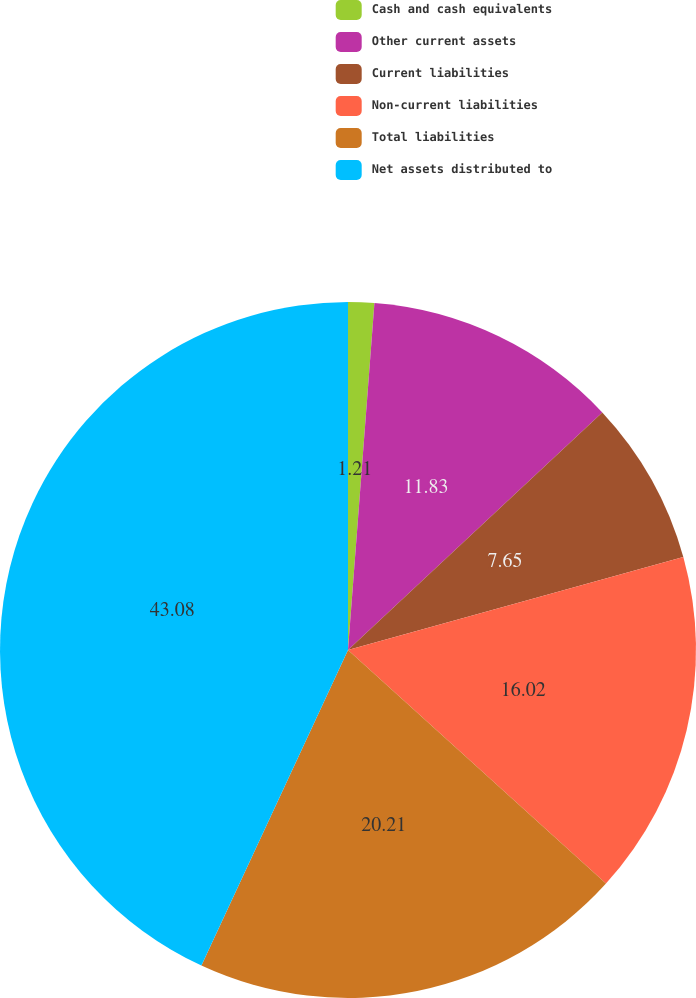Convert chart to OTSL. <chart><loc_0><loc_0><loc_500><loc_500><pie_chart><fcel>Cash and cash equivalents<fcel>Other current assets<fcel>Current liabilities<fcel>Non-current liabilities<fcel>Total liabilities<fcel>Net assets distributed to<nl><fcel>1.21%<fcel>11.83%<fcel>7.65%<fcel>16.02%<fcel>20.21%<fcel>43.08%<nl></chart> 